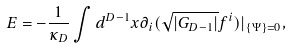Convert formula to latex. <formula><loc_0><loc_0><loc_500><loc_500>E = - \frac { 1 } { \kappa _ { D } } \int d ^ { D - 1 } x \partial _ { i } ( \sqrt { | G _ { D - 1 } | } f ^ { i } ) | _ { \{ \Psi \} = 0 } ,</formula> 